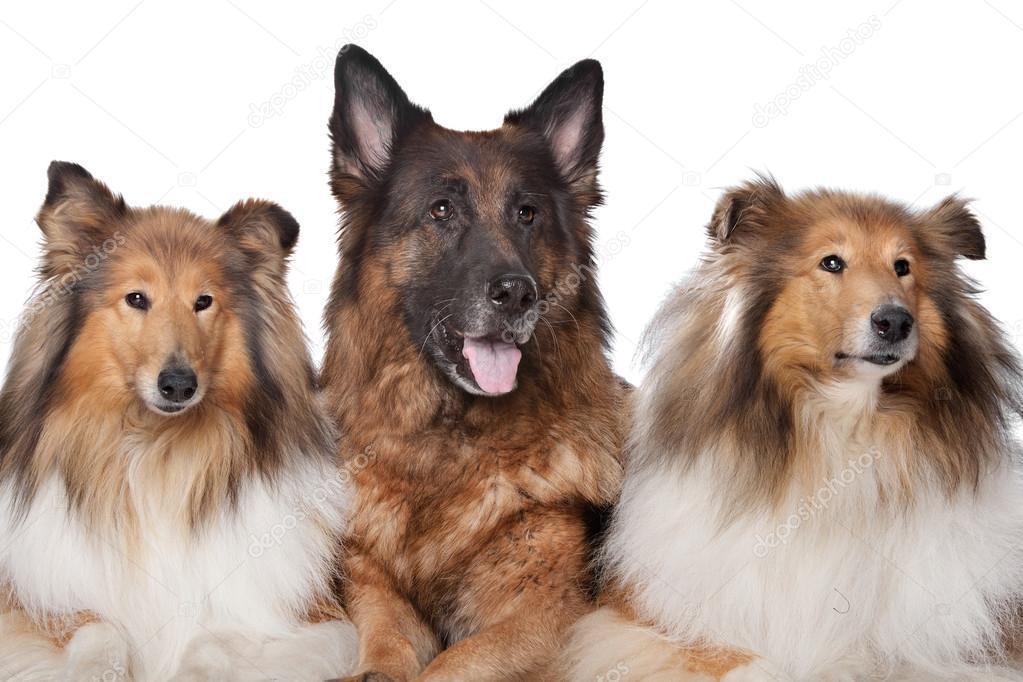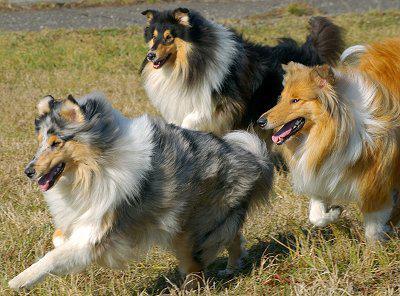The first image is the image on the left, the second image is the image on the right. For the images shown, is this caption "There are five collies in total." true? Answer yes or no. No. 